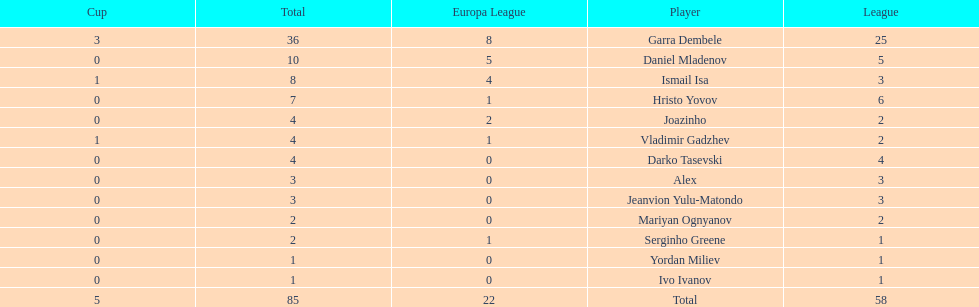Which players have at least 4 in the europa league? Garra Dembele, Daniel Mladenov, Ismail Isa. 